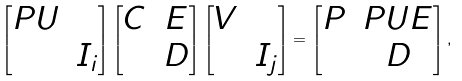<formula> <loc_0><loc_0><loc_500><loc_500>\left [ \begin{matrix} P U & \\ & I _ { i } \end{matrix} \right ] \left [ \begin{matrix} C & E \\ & D \end{matrix} \right ] \left [ \begin{matrix} V & \\ & I _ { j } \end{matrix} \right ] = \left [ \begin{matrix} P & P U E \\ & D \end{matrix} \right ] ,</formula> 